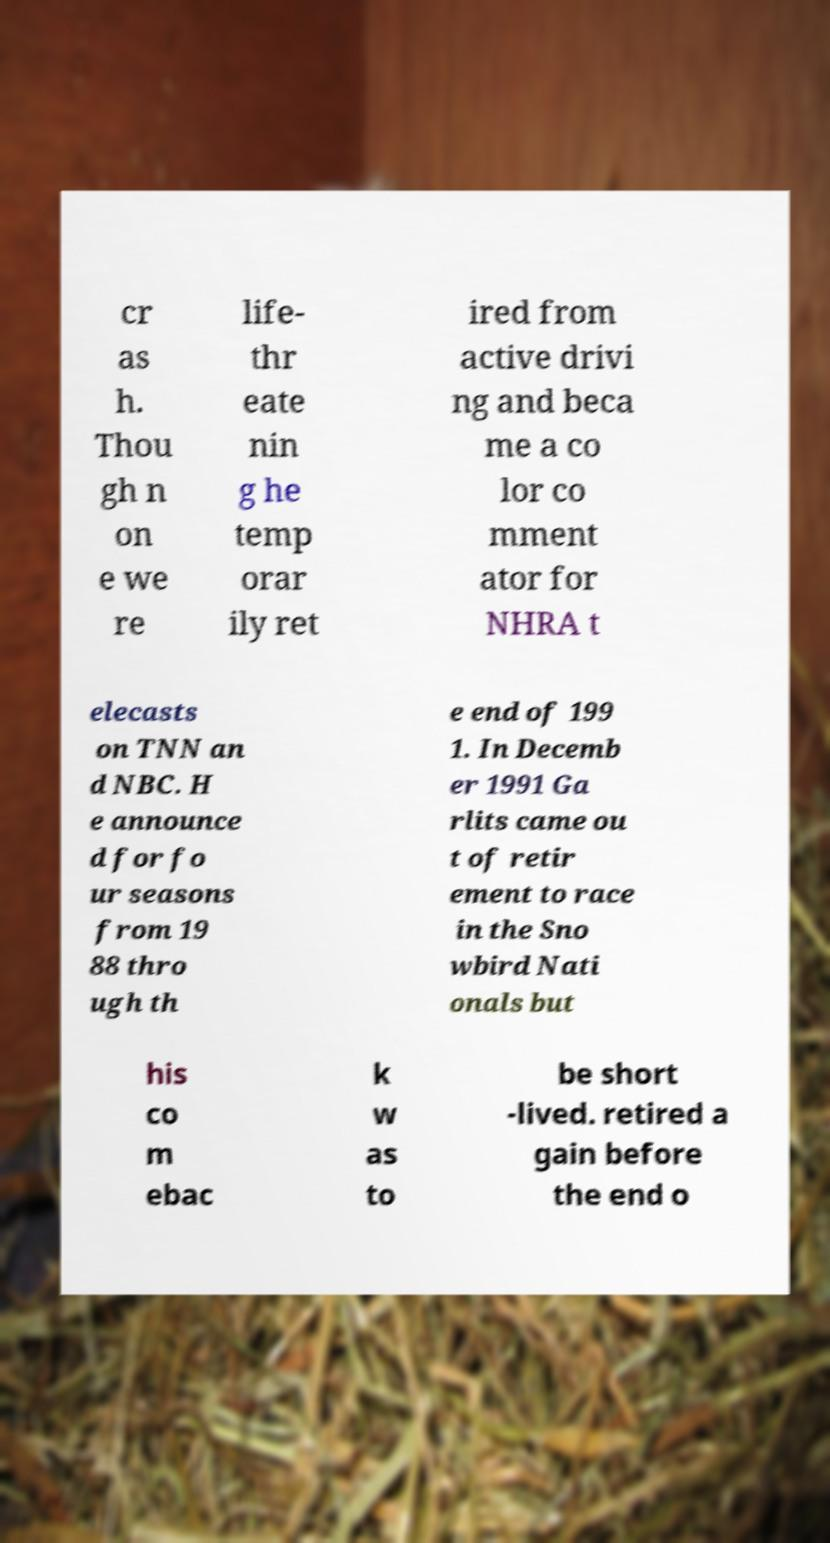Please identify and transcribe the text found in this image. cr as h. Thou gh n on e we re life- thr eate nin g he temp orar ily ret ired from active drivi ng and beca me a co lor co mment ator for NHRA t elecasts on TNN an d NBC. H e announce d for fo ur seasons from 19 88 thro ugh th e end of 199 1. In Decemb er 1991 Ga rlits came ou t of retir ement to race in the Sno wbird Nati onals but his co m ebac k w as to be short -lived. retired a gain before the end o 